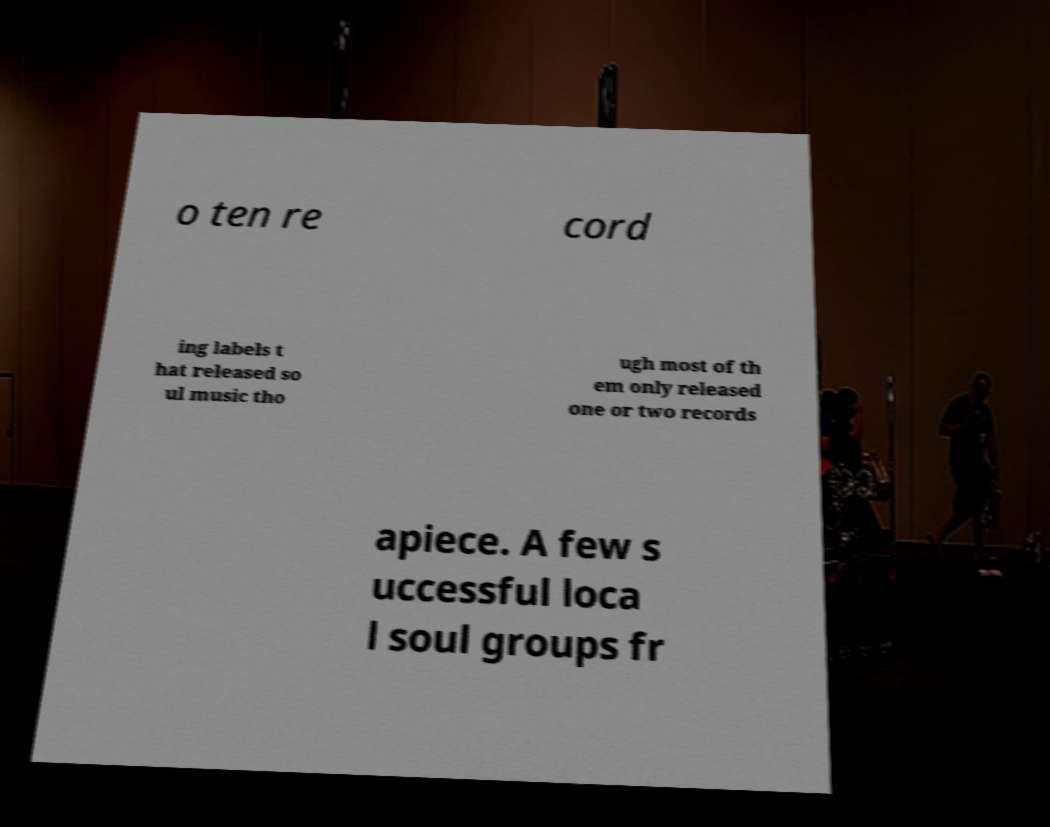Can you read and provide the text displayed in the image?This photo seems to have some interesting text. Can you extract and type it out for me? o ten re cord ing labels t hat released so ul music tho ugh most of th em only released one or two records apiece. A few s uccessful loca l soul groups fr 